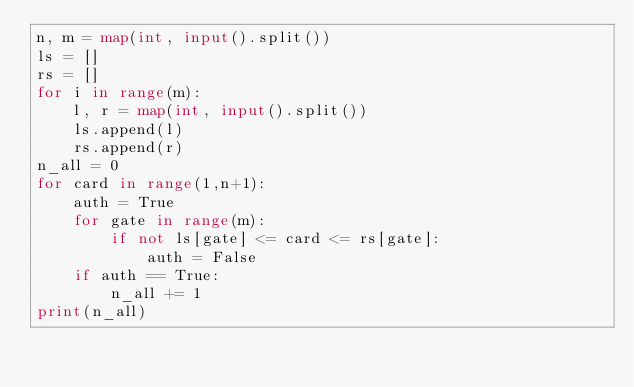Convert code to text. <code><loc_0><loc_0><loc_500><loc_500><_Python_>n, m = map(int, input().split())
ls = []
rs = []
for i in range(m):
    l, r = map(int, input().split())
    ls.append(l)
    rs.append(r)
n_all = 0
for card in range(1,n+1):
    auth = True
    for gate in range(m):
        if not ls[gate] <= card <= rs[gate]:
            auth = False
    if auth == True:
        n_all += 1
print(n_all)</code> 